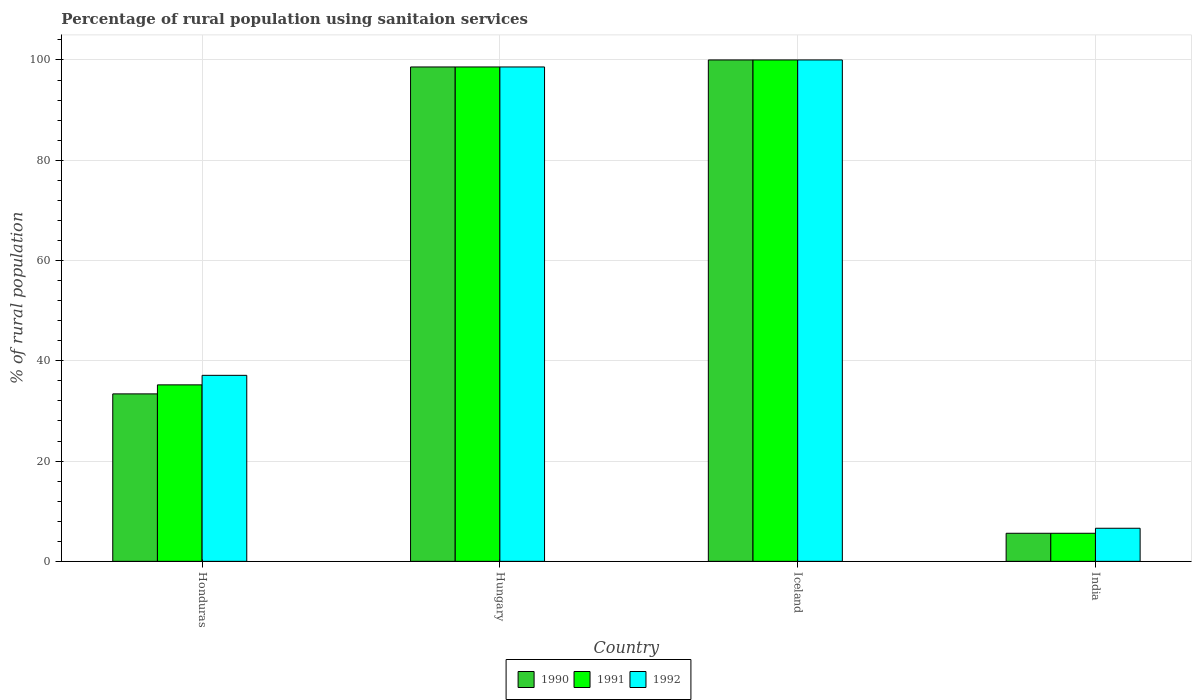How many different coloured bars are there?
Provide a short and direct response. 3. Are the number of bars per tick equal to the number of legend labels?
Make the answer very short. Yes. What is the label of the 2nd group of bars from the left?
Your answer should be compact. Hungary. Across all countries, what is the maximum percentage of rural population using sanitaion services in 1992?
Make the answer very short. 100. In which country was the percentage of rural population using sanitaion services in 1991 maximum?
Provide a short and direct response. Iceland. In which country was the percentage of rural population using sanitaion services in 1990 minimum?
Your answer should be very brief. India. What is the total percentage of rural population using sanitaion services in 1990 in the graph?
Your answer should be compact. 237.6. What is the difference between the percentage of rural population using sanitaion services in 1991 in Honduras and that in Hungary?
Provide a short and direct response. -63.4. What is the difference between the percentage of rural population using sanitaion services in 1991 in India and the percentage of rural population using sanitaion services in 1992 in Hungary?
Give a very brief answer. -93. What is the average percentage of rural population using sanitaion services in 1991 per country?
Offer a terse response. 59.85. What is the difference between the percentage of rural population using sanitaion services of/in 1992 and percentage of rural population using sanitaion services of/in 1990 in Iceland?
Ensure brevity in your answer.  0. What is the ratio of the percentage of rural population using sanitaion services in 1992 in Honduras to that in Iceland?
Keep it short and to the point. 0.37. What is the difference between the highest and the second highest percentage of rural population using sanitaion services in 1991?
Provide a short and direct response. 63.4. What is the difference between the highest and the lowest percentage of rural population using sanitaion services in 1991?
Provide a short and direct response. 94.4. In how many countries, is the percentage of rural population using sanitaion services in 1991 greater than the average percentage of rural population using sanitaion services in 1991 taken over all countries?
Your answer should be very brief. 2. Is the sum of the percentage of rural population using sanitaion services in 1992 in Honduras and India greater than the maximum percentage of rural population using sanitaion services in 1990 across all countries?
Your answer should be very brief. No. How many bars are there?
Give a very brief answer. 12. How many countries are there in the graph?
Offer a very short reply. 4. What is the difference between two consecutive major ticks on the Y-axis?
Offer a very short reply. 20. Does the graph contain any zero values?
Your answer should be compact. No. Where does the legend appear in the graph?
Your response must be concise. Bottom center. What is the title of the graph?
Ensure brevity in your answer.  Percentage of rural population using sanitaion services. What is the label or title of the Y-axis?
Your answer should be compact. % of rural population. What is the % of rural population in 1990 in Honduras?
Ensure brevity in your answer.  33.4. What is the % of rural population of 1991 in Honduras?
Offer a terse response. 35.2. What is the % of rural population of 1992 in Honduras?
Your response must be concise. 37.1. What is the % of rural population in 1990 in Hungary?
Give a very brief answer. 98.6. What is the % of rural population of 1991 in Hungary?
Provide a succinct answer. 98.6. What is the % of rural population in 1992 in Hungary?
Give a very brief answer. 98.6. What is the % of rural population in 1991 in Iceland?
Your answer should be compact. 100. What is the % of rural population in 1990 in India?
Offer a terse response. 5.6. Across all countries, what is the minimum % of rural population in 1992?
Offer a very short reply. 6.6. What is the total % of rural population of 1990 in the graph?
Give a very brief answer. 237.6. What is the total % of rural population of 1991 in the graph?
Offer a terse response. 239.4. What is the total % of rural population of 1992 in the graph?
Provide a succinct answer. 242.3. What is the difference between the % of rural population in 1990 in Honduras and that in Hungary?
Offer a terse response. -65.2. What is the difference between the % of rural population in 1991 in Honduras and that in Hungary?
Offer a terse response. -63.4. What is the difference between the % of rural population of 1992 in Honduras and that in Hungary?
Your answer should be very brief. -61.5. What is the difference between the % of rural population in 1990 in Honduras and that in Iceland?
Offer a very short reply. -66.6. What is the difference between the % of rural population in 1991 in Honduras and that in Iceland?
Provide a succinct answer. -64.8. What is the difference between the % of rural population of 1992 in Honduras and that in Iceland?
Your response must be concise. -62.9. What is the difference between the % of rural population in 1990 in Honduras and that in India?
Offer a terse response. 27.8. What is the difference between the % of rural population in 1991 in Honduras and that in India?
Your response must be concise. 29.6. What is the difference between the % of rural population in 1992 in Honduras and that in India?
Provide a short and direct response. 30.5. What is the difference between the % of rural population of 1990 in Hungary and that in Iceland?
Ensure brevity in your answer.  -1.4. What is the difference between the % of rural population of 1991 in Hungary and that in Iceland?
Offer a terse response. -1.4. What is the difference between the % of rural population of 1990 in Hungary and that in India?
Keep it short and to the point. 93. What is the difference between the % of rural population in 1991 in Hungary and that in India?
Your answer should be compact. 93. What is the difference between the % of rural population in 1992 in Hungary and that in India?
Make the answer very short. 92. What is the difference between the % of rural population of 1990 in Iceland and that in India?
Your answer should be very brief. 94.4. What is the difference between the % of rural population in 1991 in Iceland and that in India?
Your response must be concise. 94.4. What is the difference between the % of rural population of 1992 in Iceland and that in India?
Ensure brevity in your answer.  93.4. What is the difference between the % of rural population of 1990 in Honduras and the % of rural population of 1991 in Hungary?
Give a very brief answer. -65.2. What is the difference between the % of rural population of 1990 in Honduras and the % of rural population of 1992 in Hungary?
Offer a terse response. -65.2. What is the difference between the % of rural population of 1991 in Honduras and the % of rural population of 1992 in Hungary?
Provide a succinct answer. -63.4. What is the difference between the % of rural population in 1990 in Honduras and the % of rural population in 1991 in Iceland?
Ensure brevity in your answer.  -66.6. What is the difference between the % of rural population in 1990 in Honduras and the % of rural population in 1992 in Iceland?
Make the answer very short. -66.6. What is the difference between the % of rural population in 1991 in Honduras and the % of rural population in 1992 in Iceland?
Provide a succinct answer. -64.8. What is the difference between the % of rural population in 1990 in Honduras and the % of rural population in 1991 in India?
Your answer should be compact. 27.8. What is the difference between the % of rural population in 1990 in Honduras and the % of rural population in 1992 in India?
Give a very brief answer. 26.8. What is the difference between the % of rural population in 1991 in Honduras and the % of rural population in 1992 in India?
Your response must be concise. 28.6. What is the difference between the % of rural population of 1990 in Hungary and the % of rural population of 1991 in India?
Your answer should be very brief. 93. What is the difference between the % of rural population of 1990 in Hungary and the % of rural population of 1992 in India?
Your answer should be compact. 92. What is the difference between the % of rural population of 1991 in Hungary and the % of rural population of 1992 in India?
Your answer should be very brief. 92. What is the difference between the % of rural population of 1990 in Iceland and the % of rural population of 1991 in India?
Make the answer very short. 94.4. What is the difference between the % of rural population of 1990 in Iceland and the % of rural population of 1992 in India?
Provide a succinct answer. 93.4. What is the difference between the % of rural population in 1991 in Iceland and the % of rural population in 1992 in India?
Give a very brief answer. 93.4. What is the average % of rural population of 1990 per country?
Provide a short and direct response. 59.4. What is the average % of rural population in 1991 per country?
Provide a succinct answer. 59.85. What is the average % of rural population of 1992 per country?
Give a very brief answer. 60.58. What is the difference between the % of rural population of 1990 and % of rural population of 1991 in Honduras?
Your answer should be compact. -1.8. What is the difference between the % of rural population in 1990 and % of rural population in 1992 in Honduras?
Your answer should be compact. -3.7. What is the difference between the % of rural population of 1991 and % of rural population of 1992 in Honduras?
Provide a succinct answer. -1.9. What is the difference between the % of rural population in 1990 and % of rural population in 1991 in Hungary?
Give a very brief answer. 0. What is the difference between the % of rural population of 1990 and % of rural population of 1992 in Hungary?
Ensure brevity in your answer.  0. What is the difference between the % of rural population in 1991 and % of rural population in 1992 in Hungary?
Offer a very short reply. 0. What is the difference between the % of rural population in 1990 and % of rural population in 1991 in Iceland?
Your response must be concise. 0. What is the difference between the % of rural population in 1990 and % of rural population in 1992 in Iceland?
Give a very brief answer. 0. What is the difference between the % of rural population of 1991 and % of rural population of 1992 in Iceland?
Ensure brevity in your answer.  0. What is the difference between the % of rural population of 1990 and % of rural population of 1991 in India?
Provide a short and direct response. 0. What is the difference between the % of rural population in 1990 and % of rural population in 1992 in India?
Keep it short and to the point. -1. What is the ratio of the % of rural population of 1990 in Honduras to that in Hungary?
Give a very brief answer. 0.34. What is the ratio of the % of rural population of 1991 in Honduras to that in Hungary?
Keep it short and to the point. 0.36. What is the ratio of the % of rural population of 1992 in Honduras to that in Hungary?
Offer a terse response. 0.38. What is the ratio of the % of rural population in 1990 in Honduras to that in Iceland?
Offer a terse response. 0.33. What is the ratio of the % of rural population of 1991 in Honduras to that in Iceland?
Offer a terse response. 0.35. What is the ratio of the % of rural population in 1992 in Honduras to that in Iceland?
Provide a succinct answer. 0.37. What is the ratio of the % of rural population of 1990 in Honduras to that in India?
Provide a succinct answer. 5.96. What is the ratio of the % of rural population of 1991 in Honduras to that in India?
Keep it short and to the point. 6.29. What is the ratio of the % of rural population of 1992 in Honduras to that in India?
Your response must be concise. 5.62. What is the ratio of the % of rural population of 1991 in Hungary to that in Iceland?
Your answer should be compact. 0.99. What is the ratio of the % of rural population in 1990 in Hungary to that in India?
Make the answer very short. 17.61. What is the ratio of the % of rural population in 1991 in Hungary to that in India?
Provide a succinct answer. 17.61. What is the ratio of the % of rural population in 1992 in Hungary to that in India?
Make the answer very short. 14.94. What is the ratio of the % of rural population of 1990 in Iceland to that in India?
Keep it short and to the point. 17.86. What is the ratio of the % of rural population of 1991 in Iceland to that in India?
Your answer should be compact. 17.86. What is the ratio of the % of rural population of 1992 in Iceland to that in India?
Make the answer very short. 15.15. What is the difference between the highest and the second highest % of rural population in 1990?
Your response must be concise. 1.4. What is the difference between the highest and the lowest % of rural population in 1990?
Offer a very short reply. 94.4. What is the difference between the highest and the lowest % of rural population of 1991?
Make the answer very short. 94.4. What is the difference between the highest and the lowest % of rural population in 1992?
Your response must be concise. 93.4. 